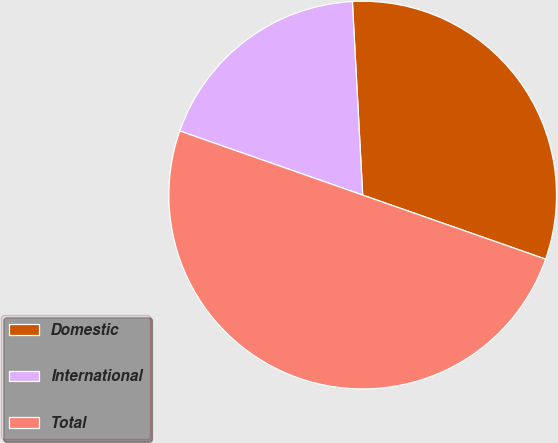Convert chart to OTSL. <chart><loc_0><loc_0><loc_500><loc_500><pie_chart><fcel>Domestic<fcel>International<fcel>Total<nl><fcel>31.21%<fcel>18.79%<fcel>50.0%<nl></chart> 